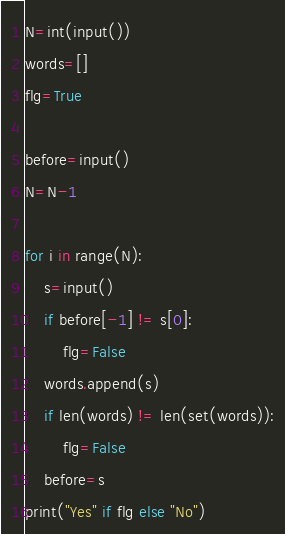<code> <loc_0><loc_0><loc_500><loc_500><_Python_>N=int(input())
words=[]
flg=True

before=input()
N=N-1

for i in range(N):
    s=input()
    if before[-1] != s[0]:
        flg=False
    words.append(s)
    if len(words) != len(set(words)):
        flg=False
    before=s
print("Yes" if flg else "No")</code> 